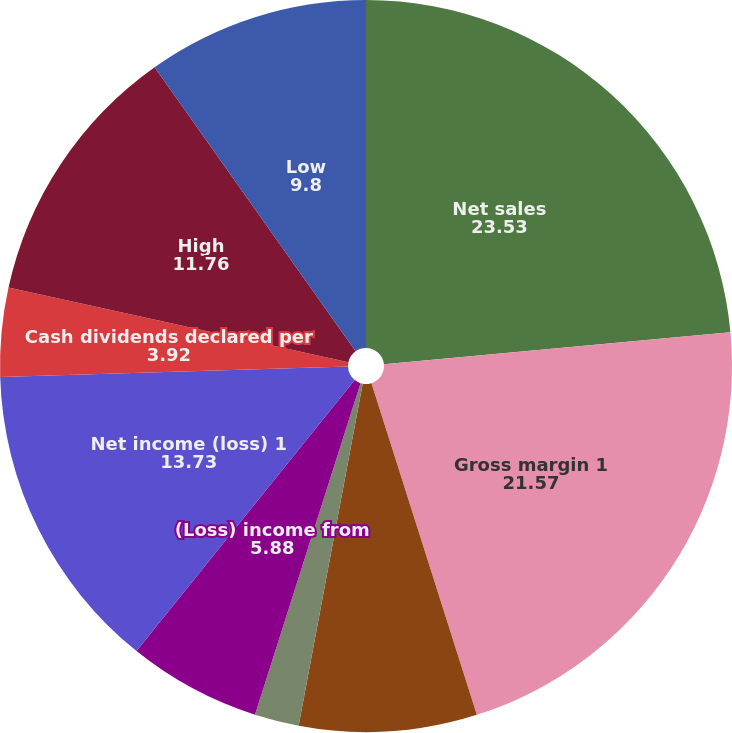<chart> <loc_0><loc_0><loc_500><loc_500><pie_chart><fcel>Net sales<fcel>Gross margin 1<fcel>Income (loss) from continuing<fcel>Basic<fcel>Diluted<fcel>(Loss) income from<fcel>Net income (loss) 1<fcel>Cash dividends declared per<fcel>High<fcel>Low<nl><fcel>23.53%<fcel>21.57%<fcel>7.84%<fcel>0.0%<fcel>1.96%<fcel>5.88%<fcel>13.73%<fcel>3.92%<fcel>11.76%<fcel>9.8%<nl></chart> 